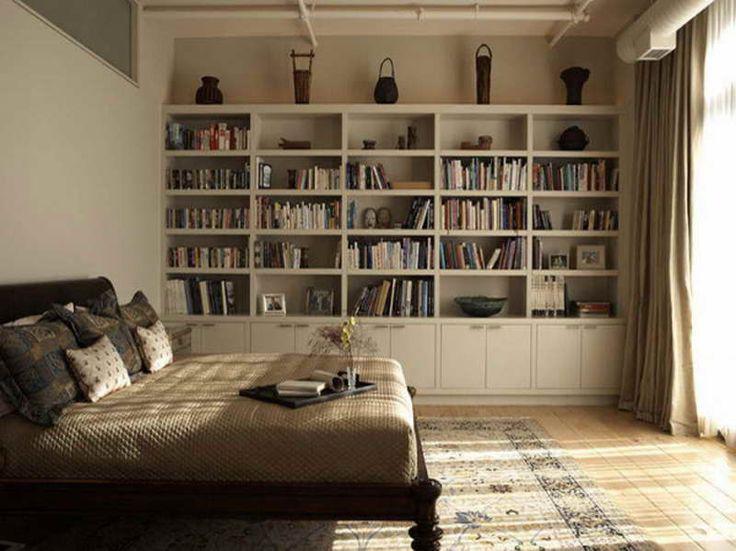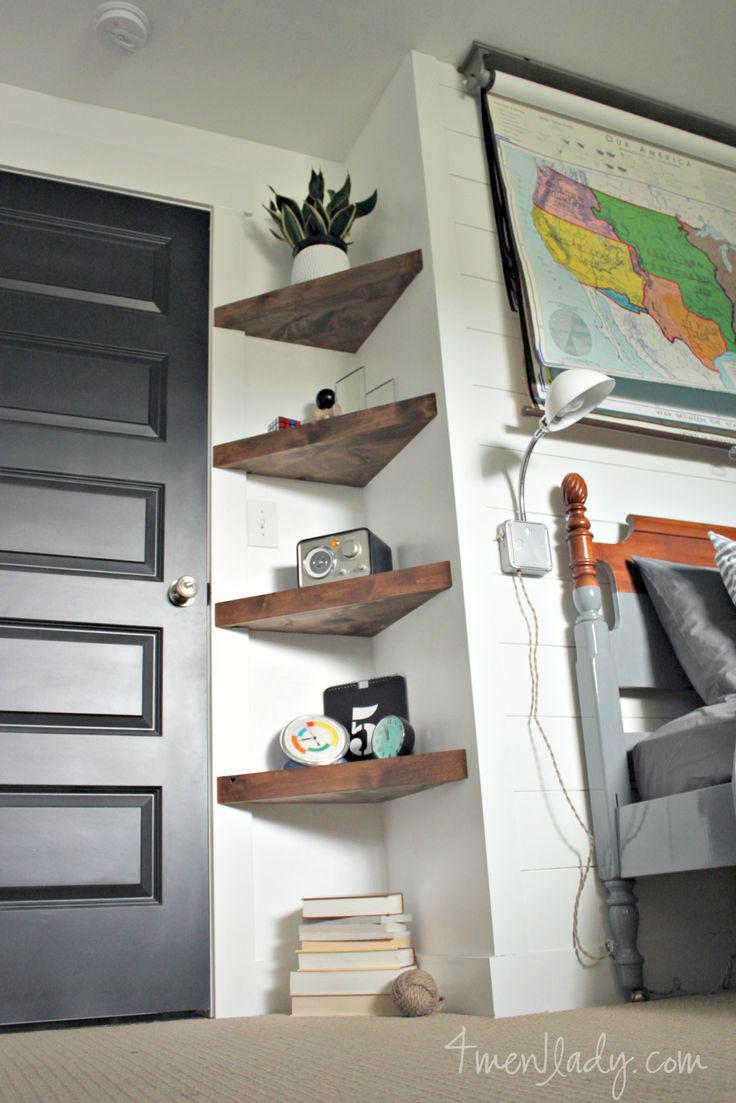The first image is the image on the left, the second image is the image on the right. Considering the images on both sides, is "A room has a platform bed with storage drawers underneath, and floating shelves on the wall behind it." valid? Answer yes or no. No. The first image is the image on the left, the second image is the image on the right. For the images displayed, is the sentence "A rug sits on the floor in the image on the left." factually correct? Answer yes or no. Yes. 